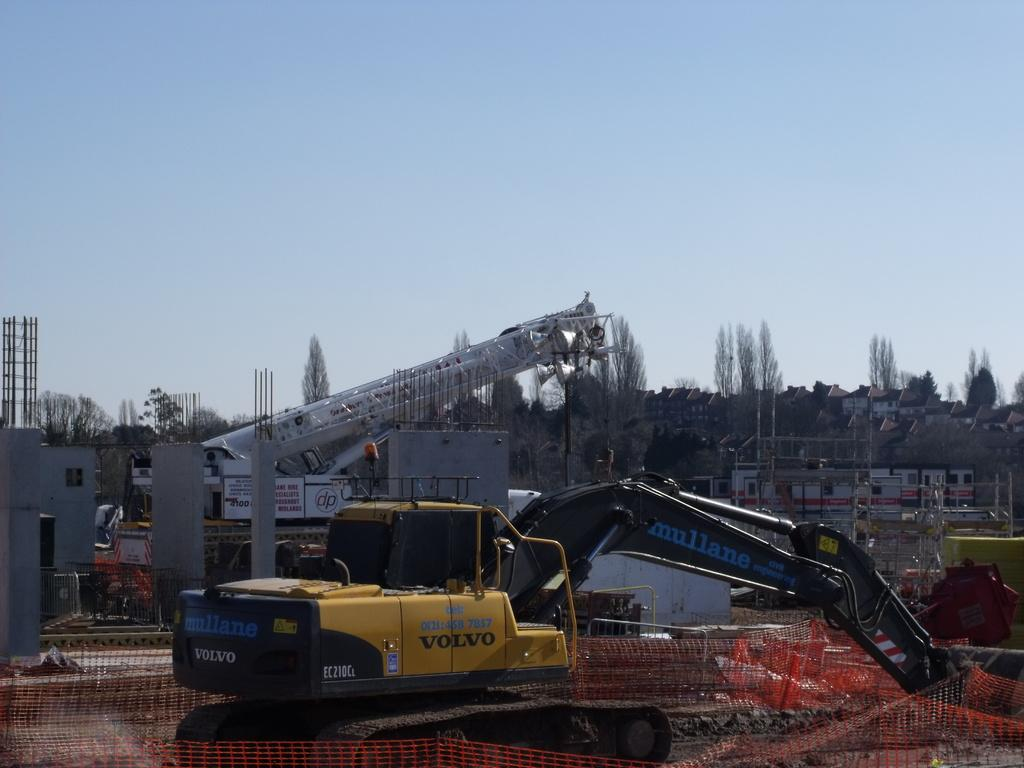What can be seen in the background of the image? There are many buildings and houses in the background of the image. What is located on the left side of the image? There is a construction site on the left side of the image. What is the main subject at the center of the image? There is a vehicle at the center of the image. How many cacti can be seen near the construction site in the image? There are no cacti present in the image. What type of frogs are hopping around the vehicle in the image? There are no frogs present in the image. 